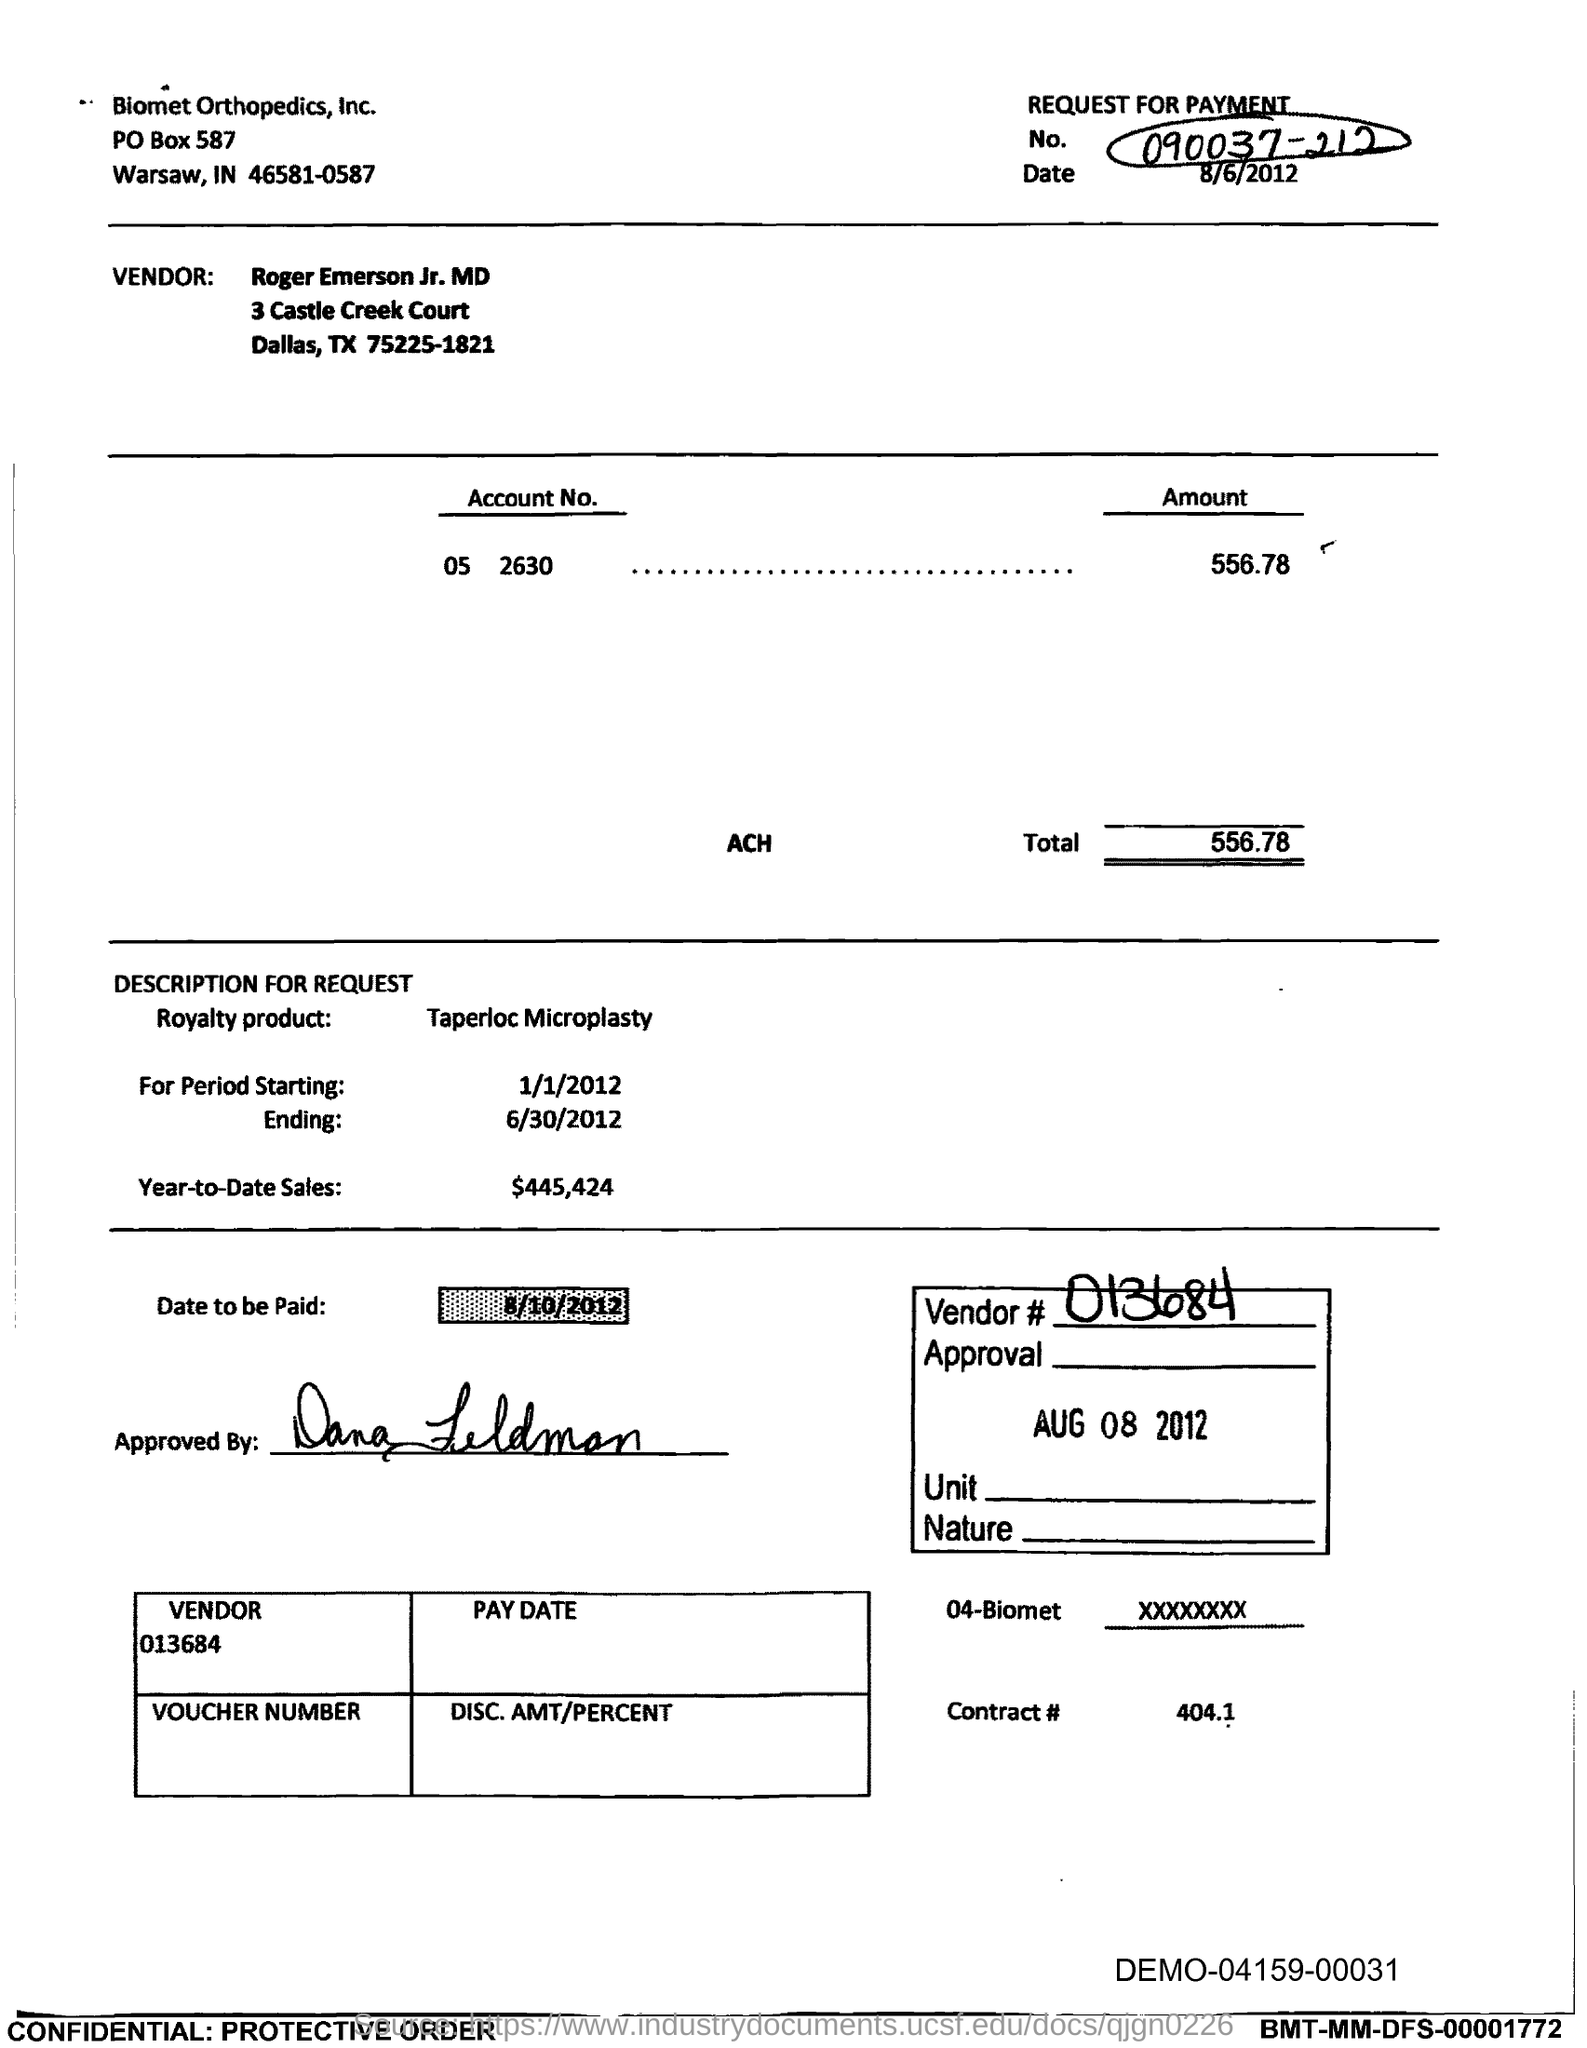What is the request for payment No. given in the document?
Give a very brief answer. 090037-212. Who is the Vendor mentioned in the document?
Offer a terse response. Roger Emerson Jr. MD. What is the Account No. given in the document?
Give a very brief answer. 05 2630. What is the amount to be paid mentioned in the document?
Provide a short and direct response. 556.78. What is the royalty product mentioned in the document?
Your answer should be compact. Taperloc Microplasty. What is the start date of the royalty period?
Make the answer very short. 1/1/2012. What is the Year-to-Date Sales of the royalty product?
Give a very brief answer. $445,424. Who has approved this document?
Provide a short and direct response. Dana Feldman. What is the vendor # given in the document?
Provide a succinct answer. 013684. 